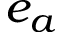<formula> <loc_0><loc_0><loc_500><loc_500>e _ { a }</formula> 